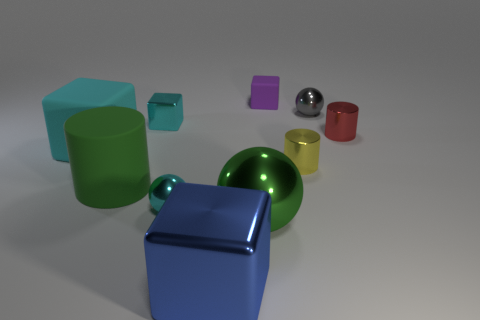Do the green cylinder and the green sphere have the same size? While they appear to be similar in size at a glance, without exact measurements it's difficult to confirm if the green cylinder and the green sphere are the same size. Factors such as perspective and distance from the viewpoint can distort visual size comparison. 